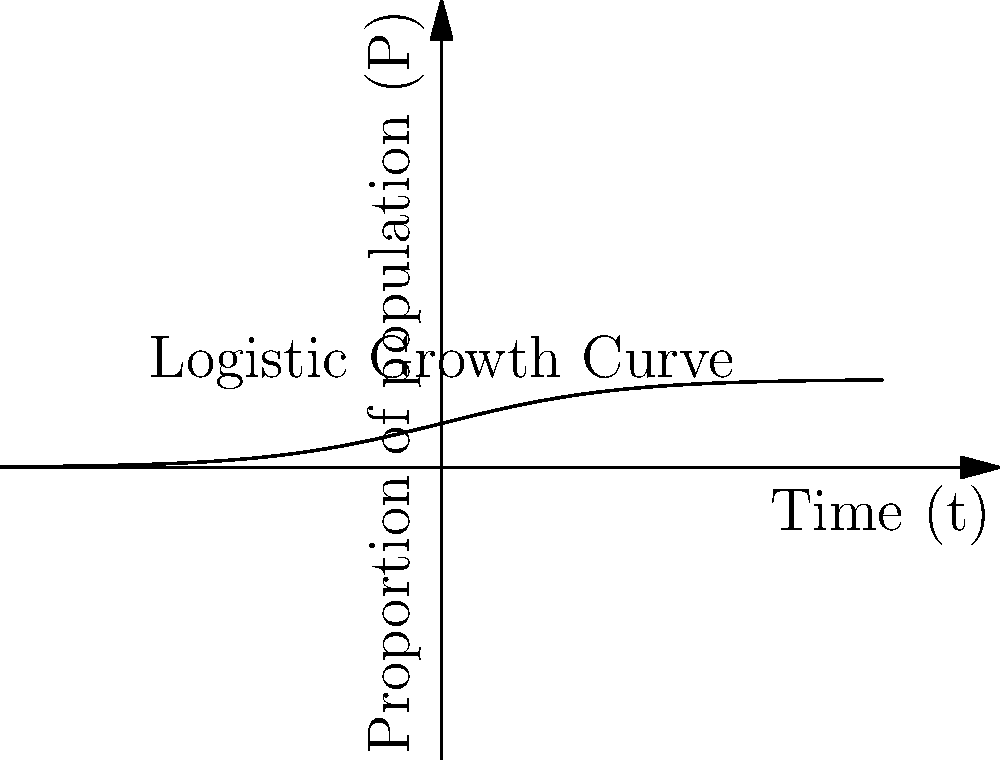Consider a simplified model of political ideology spread using the logistic growth equation:

$$ \frac{dP}{dt} = rP(1-P) $$

Where $P$ represents the proportion of the population adhering to a particular ideology, $t$ is time, and $r$ is the growth rate. If $r=0.5$ and initially 10% of the population adheres to the ideology, at what time $t$ will half of the population adopt this ideology? To solve this problem, we'll follow these steps:

1) The logistic growth equation has the solution:

   $$ P(t) = \frac{1}{1 + (\frac{1}{P_0} - 1)e^{-rt}} $$

   Where $P_0$ is the initial proportion.

2) We're given:
   - $r = 0.5$
   - $P_0 = 0.1$ (10% initial adoption)
   - We want to find $t$ when $P(t) = 0.5$ (50% adoption)

3) Substituting these values into the equation:

   $$ 0.5 = \frac{1}{1 + (\frac{1}{0.1} - 1)e^{-0.5t}} $$

4) Simplify:
   $$ 0.5 = \frac{1}{1 + 9e^{-0.5t}} $$

5) Multiply both sides by the denominator:
   $$ 0.5(1 + 9e^{-0.5t}) = 1 $$
   $$ 0.5 + 4.5e^{-0.5t} = 1 $$

6) Subtract 0.5 from both sides:
   $$ 4.5e^{-0.5t} = 0.5 $$

7) Divide both sides by 4.5:
   $$ e^{-0.5t} = \frac{1}{9} $$

8) Take the natural log of both sides:
   $$ -0.5t = \ln(\frac{1}{9}) = -\ln(9) $$

9) Solve for t:
   $$ t = \frac{2\ln(9)}{0.5} = 4\ln(9) \approx 8.78 $$

Therefore, it will take approximately 8.78 time units for half of the population to adopt the ideology.
Answer: $4\ln(9)$ or approximately 8.78 time units 